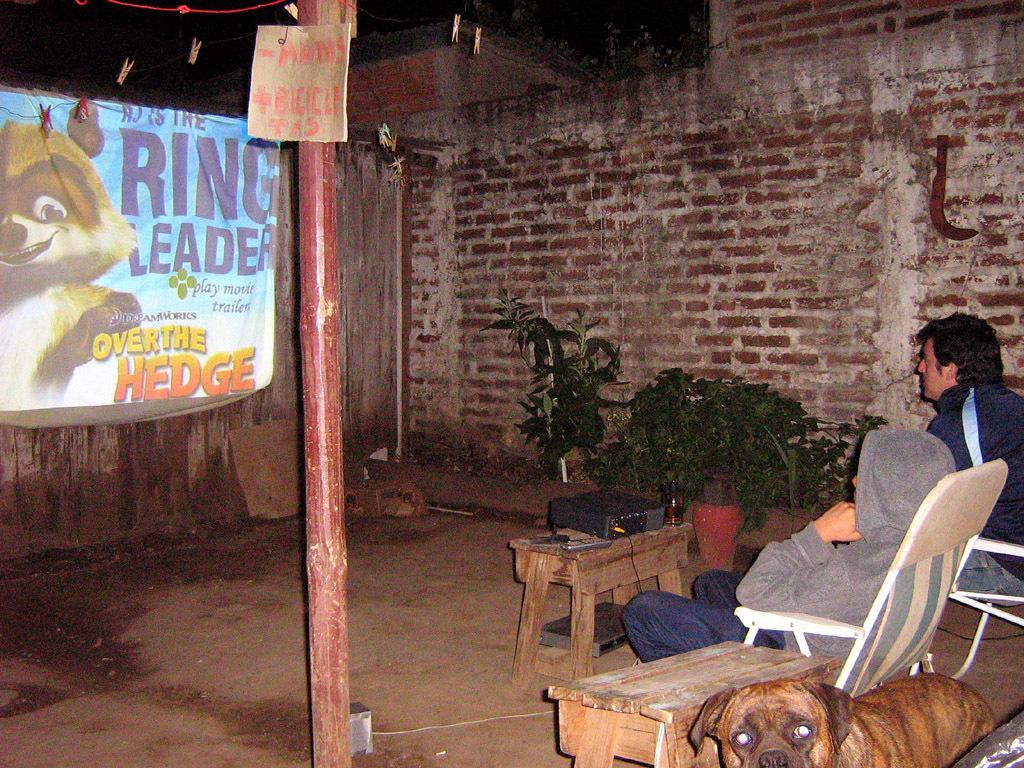In one or two sentences, can you explain what this image depicts? In this image there are 2 persons sitting in the chairs , there is a dog, plants, tables, projector, name board attached to a pole , a screen , wall, clips, rope, knife. 